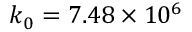Convert formula to latex. <formula><loc_0><loc_0><loc_500><loc_500>k _ { 0 } = 7 . 4 8 \times 1 0 ^ { 6 }</formula> 